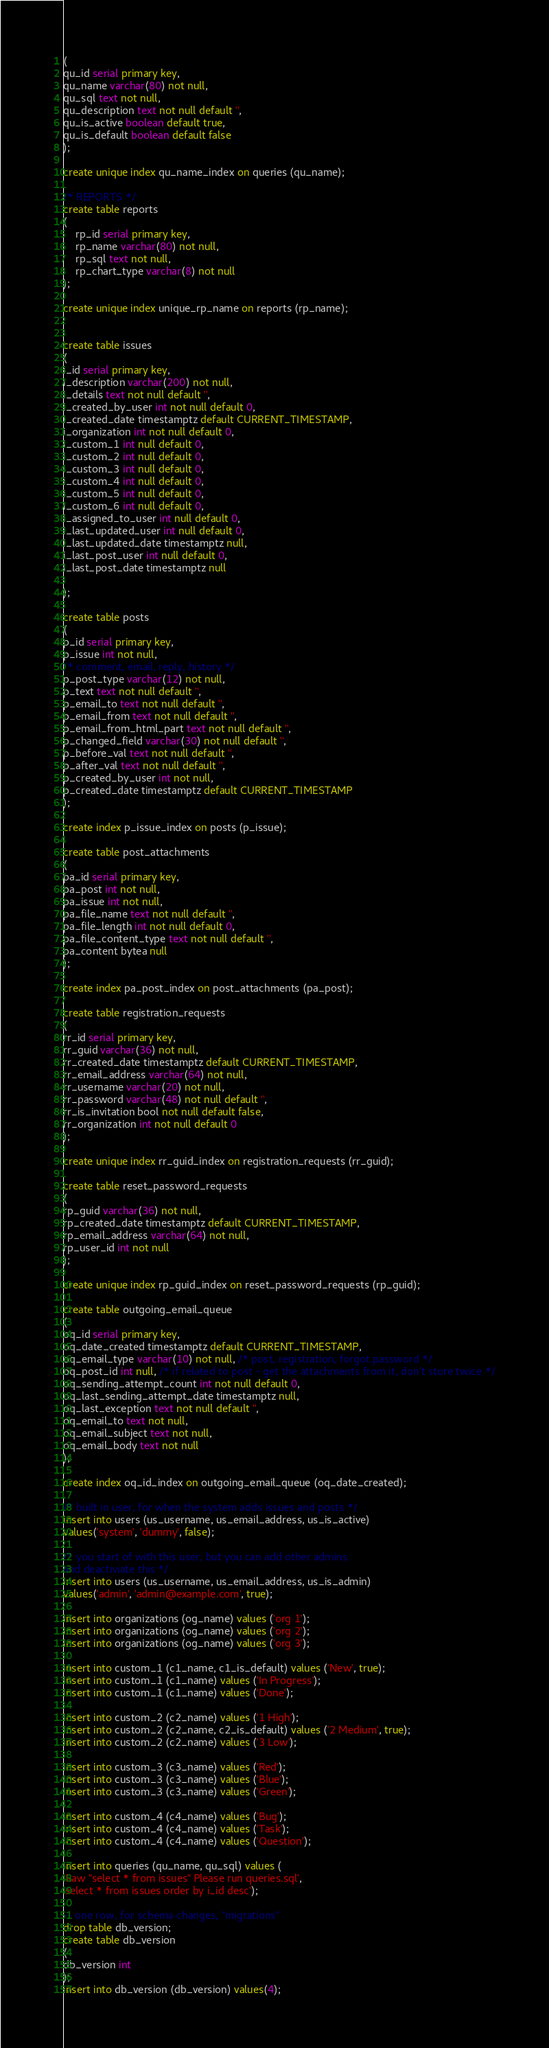Convert code to text. <code><loc_0><loc_0><loc_500><loc_500><_SQL_>(
qu_id serial primary key,
qu_name varchar(80) not null,
qu_sql text not null,
qu_description text not null default '',
qu_is_active boolean default true,
qu_is_default boolean default false
);

create unique index qu_name_index on queries (qu_name);

/* REPORTS */
create table reports
(
	rp_id serial primary key,
	rp_name varchar(80) not null,
	rp_sql text not null,
	rp_chart_type varchar(8) not null
);

create unique index unique_rp_name on reports (rp_name);


create table issues 
(
i_id serial primary key,
i_description varchar(200) not null,
i_details text not null default '',
i_created_by_user int not null default 0,
i_created_date timestamptz default CURRENT_TIMESTAMP,
i_organization int not null default 0,
i_custom_1 int null default 0,
i_custom_2 int null default 0,
i_custom_3 int null default 0,
i_custom_4 int null default 0,
i_custom_5 int null default 0,
i_custom_6 int null default 0,
i_assigned_to_user int null default 0,
i_last_updated_user int null default 0,
i_last_updated_date timestamptz null,
i_last_post_user int null default 0,
i_last_post_date timestamptz null

);

create table posts 
(
p_id serial primary key,
p_issue int not null,
/* comment, email, reply, history */
p_post_type varchar(12) not null,
p_text text not null default '',
p_email_to text not null default '',
p_email_from text not null default '',
p_email_from_html_part text not null default '',
p_changed_field varchar(30) not null default '',
p_before_val text not null default '',
p_after_val text not null default '',
p_created_by_user int not null,
p_created_date timestamptz default CURRENT_TIMESTAMP
);

create index p_issue_index on posts (p_issue);

create table post_attachments
(
pa_id serial primary key,
pa_post int not null,
pa_issue int not null, 
pa_file_name text not null default '',
pa_file_length int not null default 0,
pa_file_content_type text not null default '',
pa_content bytea null
);

create index pa_post_index on post_attachments (pa_post);

create table registration_requests
(
rr_id serial primary key,
rr_guid varchar(36) not null,
rr_created_date timestamptz default CURRENT_TIMESTAMP,
rr_email_address varchar(64) not null,
rr_username varchar(20) not null,
rr_password varchar(48) not null default '',
rr_is_invitation bool not null default false,
rr_organization int not null default 0
);

create unique index rr_guid_index on registration_requests (rr_guid);

create table reset_password_requests
(
rp_guid varchar(36) not null,
rp_created_date timestamptz default CURRENT_TIMESTAMP,
rp_email_address varchar(64) not null,
rp_user_id int not null
);

create unique index rp_guid_index on reset_password_requests (rp_guid);

create table outgoing_email_queue 
(
oq_id serial primary key,
oq_date_created timestamptz default CURRENT_TIMESTAMP,
oq_email_type varchar(10) not null, /* post, registration, forgot password */
oq_post_id int null, /* if related to post - get the attachments from it, don't store twice */
oq_sending_attempt_count int not null default 0,
oq_last_sending_attempt_date timestamptz null,
oq_last_exception text not null default '',
oq_email_to text not null,
oq_email_subject text not null,
oq_email_body text not null
);

create index oq_id_index on outgoing_email_queue (oq_date_created);

/* built in user, for when the system adds issues and posts */
insert into users (us_username, us_email_address, us_is_active) 
values('system', 'dummy', false);

/* you start of with this user, but you can add other admins 
and deactiviate this */
insert into users (us_username, us_email_address, us_is_admin) 
values('admin', 'admin@example.com', true);

insert into organizations (og_name) values ('org 1');
insert into organizations (og_name) values ('org 2');
insert into organizations (og_name) values ('org 3');

insert into custom_1 (c1_name, c1_is_default) values ('New', true);
insert into custom_1 (c1_name) values ('In Progress');
insert into custom_1 (c1_name) values ('Done');

insert into custom_2 (c2_name) values ('1 High');
insert into custom_2 (c2_name, c2_is_default) values ('2 Medium', true);
insert into custom_2 (c2_name) values ('3 Low');

insert into custom_3 (c3_name) values ('Red');
insert into custom_3 (c3_name) values ('Blue');
insert into custom_3 (c3_name) values ('Green');

insert into custom_4 (c4_name) values ('Bug');
insert into custom_4 (c4_name) values ('Task');
insert into custom_4 (c4_name) values ('Question');

insert into queries (qu_name, qu_sql) values (
'Raw "select * from issues" Please run queries.sql',
'select * from issues order by i_id desc');

-- one row, for schema changes, "migrations"
drop table db_version;
create table db_version
(
db_version int 
);
insert into db_version (db_version) values(4);
</code> 